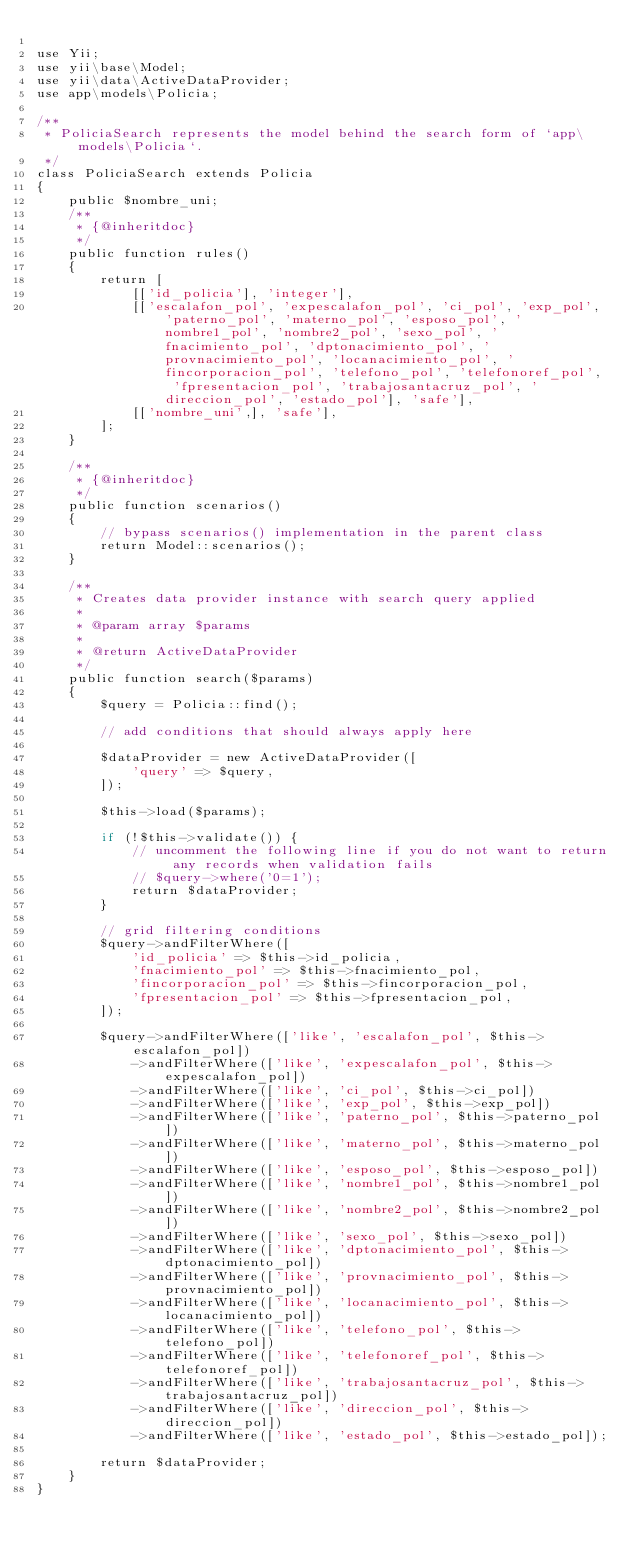Convert code to text. <code><loc_0><loc_0><loc_500><loc_500><_PHP_>
use Yii;
use yii\base\Model;
use yii\data\ActiveDataProvider;
use app\models\Policia;

/**
 * PoliciaSearch represents the model behind the search form of `app\models\Policia`.
 */
class PoliciaSearch extends Policia
{
    public $nombre_uni;
    /**
     * {@inheritdoc}
     */
    public function rules()
    {
        return [
            [['id_policia'], 'integer'],
            [['escalafon_pol', 'expescalafon_pol', 'ci_pol', 'exp_pol', 'paterno_pol', 'materno_pol', 'esposo_pol', 'nombre1_pol', 'nombre2_pol', 'sexo_pol', 'fnacimiento_pol', 'dptonacimiento_pol', 'provnacimiento_pol', 'locanacimiento_pol', 'fincorporacion_pol', 'telefono_pol', 'telefonoref_pol', 'fpresentacion_pol', 'trabajosantacruz_pol', 'direccion_pol', 'estado_pol'], 'safe'],
            [['nombre_uni',], 'safe'],
        ];
    }

    /**
     * {@inheritdoc}
     */
    public function scenarios()
    {
        // bypass scenarios() implementation in the parent class
        return Model::scenarios();
    }

    /**
     * Creates data provider instance with search query applied
     *
     * @param array $params
     *
     * @return ActiveDataProvider
     */
    public function search($params)
    {
        $query = Policia::find();

        // add conditions that should always apply here

        $dataProvider = new ActiveDataProvider([
            'query' => $query,
        ]);

        $this->load($params);

        if (!$this->validate()) {
            // uncomment the following line if you do not want to return any records when validation fails
            // $query->where('0=1');
            return $dataProvider;
        }

        // grid filtering conditions
        $query->andFilterWhere([
            'id_policia' => $this->id_policia,
            'fnacimiento_pol' => $this->fnacimiento_pol,
            'fincorporacion_pol' => $this->fincorporacion_pol,
            'fpresentacion_pol' => $this->fpresentacion_pol,
        ]);

        $query->andFilterWhere(['like', 'escalafon_pol', $this->escalafon_pol])
            ->andFilterWhere(['like', 'expescalafon_pol', $this->expescalafon_pol])
            ->andFilterWhere(['like', 'ci_pol', $this->ci_pol])
            ->andFilterWhere(['like', 'exp_pol', $this->exp_pol])
            ->andFilterWhere(['like', 'paterno_pol', $this->paterno_pol])
            ->andFilterWhere(['like', 'materno_pol', $this->materno_pol])
            ->andFilterWhere(['like', 'esposo_pol', $this->esposo_pol])
            ->andFilterWhere(['like', 'nombre1_pol', $this->nombre1_pol])
            ->andFilterWhere(['like', 'nombre2_pol', $this->nombre2_pol])
            ->andFilterWhere(['like', 'sexo_pol', $this->sexo_pol])
            ->andFilterWhere(['like', 'dptonacimiento_pol', $this->dptonacimiento_pol])
            ->andFilterWhere(['like', 'provnacimiento_pol', $this->provnacimiento_pol])
            ->andFilterWhere(['like', 'locanacimiento_pol', $this->locanacimiento_pol])
            ->andFilterWhere(['like', 'telefono_pol', $this->telefono_pol])
            ->andFilterWhere(['like', 'telefonoref_pol', $this->telefonoref_pol])
            ->andFilterWhere(['like', 'trabajosantacruz_pol', $this->trabajosantacruz_pol])
            ->andFilterWhere(['like', 'direccion_pol', $this->direccion_pol])
            ->andFilterWhere(['like', 'estado_pol', $this->estado_pol]);

        return $dataProvider;
    }
}
</code> 